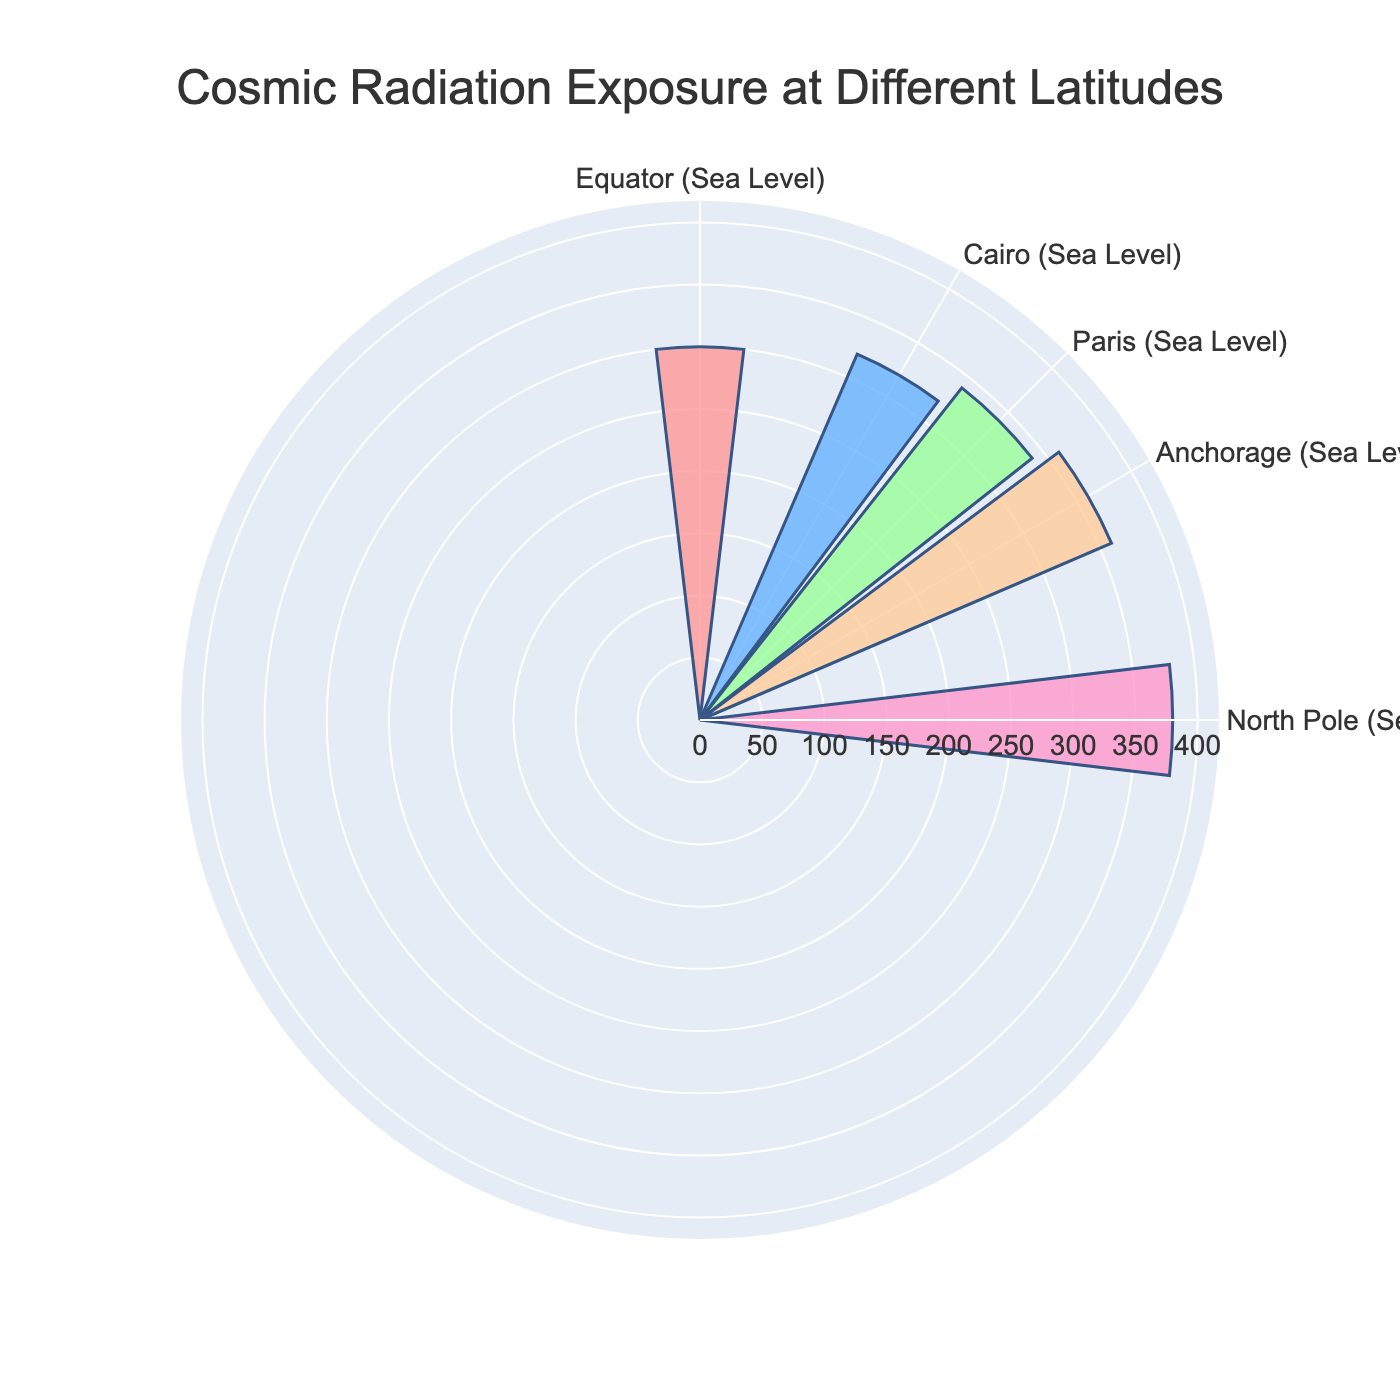What is the title of the figure? The title is clearly located at the top center of the figure. It reads “Cosmic Radiation Exposure at Different Latitudes”.
Answer: Cosmic Radiation Exposure at Different Latitudes What are the locations marked on the angular axis? The angular axis has tick marks representing the different locations along with their corresponding latitudes. The tick marks are for Equator (0°), Cairo (30°), Paris (45°), Anchorage (60°), and North Pole (90°).
Answer: Equator, Cairo, Paris, Anchorage, North Pole Which location has the highest frequency of cosmic radiation exposure? By looking at the lengths of the bars in the rose chart, the North Pole, with a latitude of 90°, has the longest bar and thus the highest frequency of exposure.
Answer: North Pole How does the frequency of cosmic radiation exposure change as we move from the Equator to the North Pole? By comparing the lengths of the bars, we can see that the frequency increases progressively from the Equator (300 µSv/year) to the North Pole (380 µSv/year). This indicates a trend of increasing exposure with higher latitudes.
Answer: Increases What is the average cosmic radiation exposure across all the locations? First, we sum the exposure values: 300 (Equator) + 320 (Cairo) + 340 (Paris) + 360 (Anchorage) + 380 (North Pole) = 1700. Then, divide by the number of data points, which is 5. The average is 1700 / 5 = 340 µSv/year.
Answer: 340 µSv/year By how much does the radiation exposure increase from Cairo to Anchorage? The exposure at Cairo is 320 µSv/year, and at Anchorage, it is 360 µSv/year. The difference is 360 - 320 = 40 µSv/year.
Answer: 40 µSv/year Which color represents the cosmic radiation exposure at Paris? The bar for Paris (45° latitude) is light green.
Answer: Light green If the total radiation exposure from Equator to North Pole is multiplied by 2, what would that value be? The sum of the exposures from Equator to North Pole is 1700 µSv/year. Multiplying this by 2 gives 1700 * 2 = 3400 µSv/year.
Answer: 3400 µSv/year Is the increase in cosmic radiation exposure uniform across all latitudes? By visually comparing the lengths of the bars, we notice that the increase in exposure is not perfectly uniform, but it generally increases as we move from the Equator to the North Pole, with some small variations.
Answer: No What is the range of cosmic radiation exposure values displayed? The range is calculated by subtracting the smallest value from the largest value. The smallest value is 300 µSv/year (Equator), and the largest is 380 µSv/year (North Pole). The range is 380 - 300 = 80 µSv/year.
Answer: 80 µSv/year 